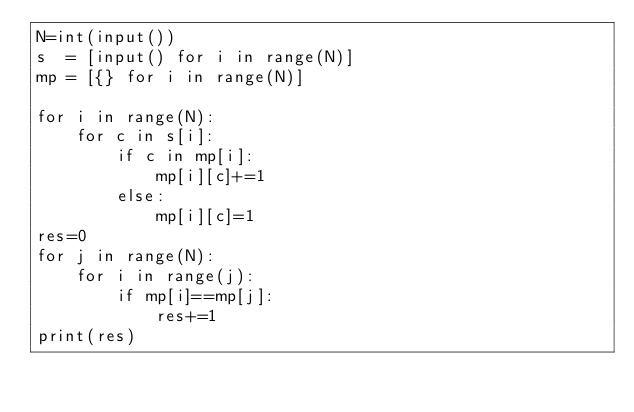Convert code to text. <code><loc_0><loc_0><loc_500><loc_500><_Python_>N=int(input())
s  = [input() for i in range(N)]
mp = [{} for i in range(N)]

for i in range(N):
    for c in s[i]:
        if c in mp[i]:
            mp[i][c]+=1
        else:
            mp[i][c]=1
res=0
for j in range(N):
    for i in range(j):
        if mp[i]==mp[j]:
            res+=1
print(res)
</code> 